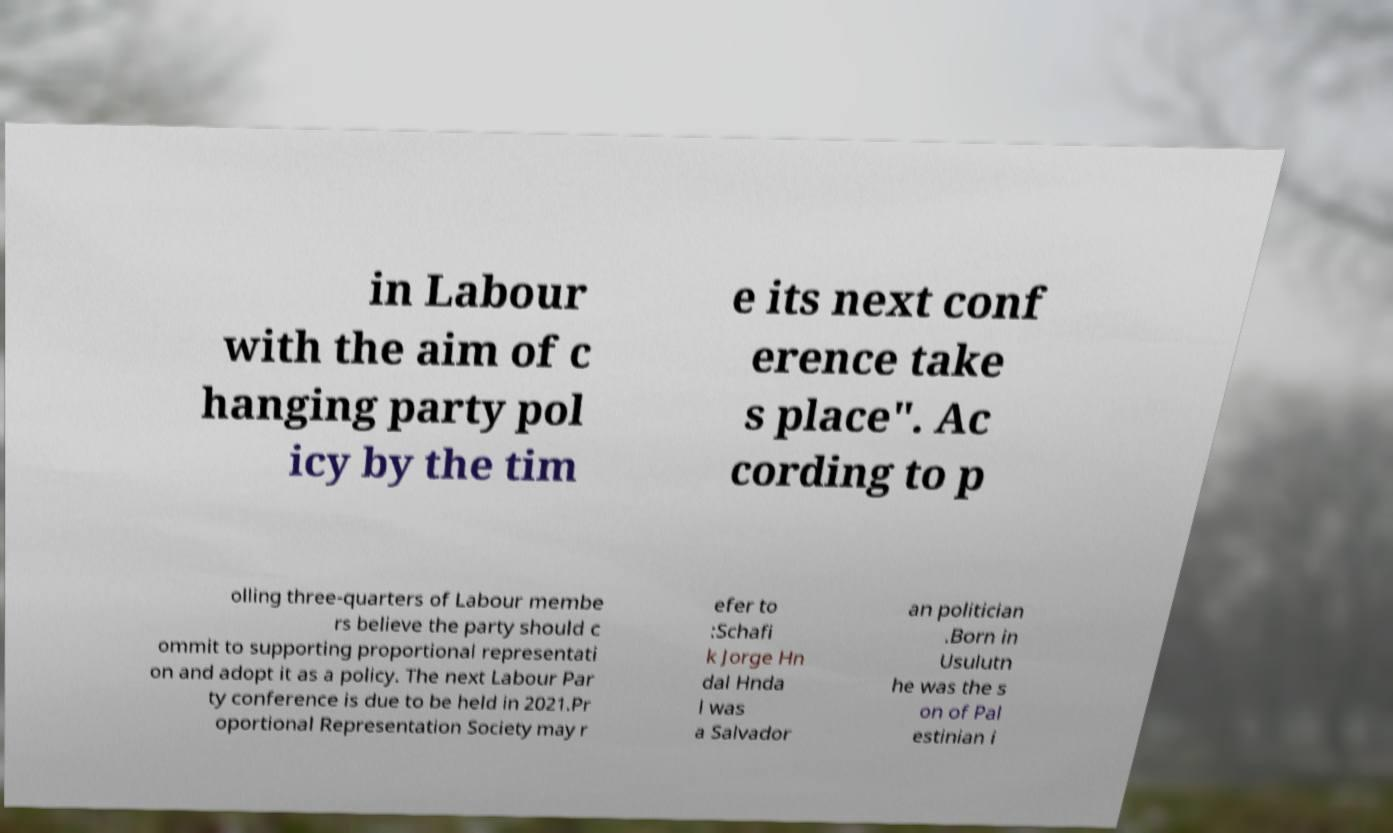I need the written content from this picture converted into text. Can you do that? in Labour with the aim of c hanging party pol icy by the tim e its next conf erence take s place". Ac cording to p olling three-quarters of Labour membe rs believe the party should c ommit to supporting proportional representati on and adopt it as a policy. The next Labour Par ty conference is due to be held in 2021.Pr oportional Representation Society may r efer to :Schafi k Jorge Hn dal Hnda l was a Salvador an politician .Born in Usulutn he was the s on of Pal estinian i 